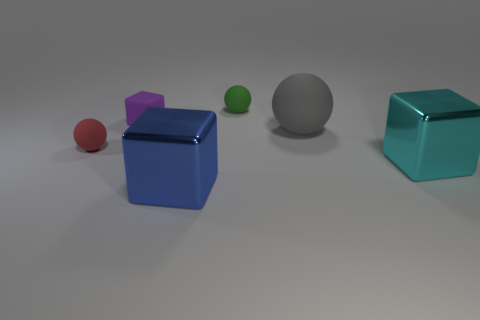The shiny thing that is on the left side of the tiny green sphere has what shape?
Ensure brevity in your answer.  Cube. There is a block that is behind the large metallic cube that is behind the big blue cube; what is its material?
Provide a succinct answer. Rubber. Are there more tiny purple rubber objects that are in front of the tiny block than large purple metal cylinders?
Ensure brevity in your answer.  No. There is a green rubber object that is the same size as the purple matte thing; what shape is it?
Your answer should be very brief. Sphere. How many large blocks are to the left of the small green rubber object that is to the left of the cyan metallic thing in front of the tiny red rubber object?
Offer a very short reply. 1. How many shiny objects are big gray objects or small purple objects?
Your answer should be compact. 0. What color is the sphere that is left of the gray ball and in front of the tiny rubber block?
Ensure brevity in your answer.  Red. Does the metallic block that is to the right of the blue shiny thing have the same size as the gray sphere?
Offer a very short reply. Yes. What number of objects are either tiny cubes left of the cyan cube or big gray things?
Provide a short and direct response. 2. Are there any yellow rubber objects of the same size as the gray thing?
Keep it short and to the point. No. 